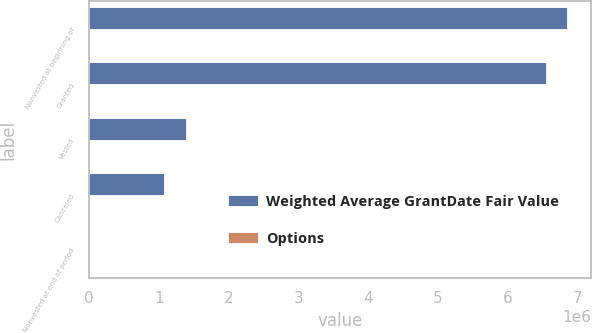<chart> <loc_0><loc_0><loc_500><loc_500><stacked_bar_chart><ecel><fcel>Nonvested at beginning of<fcel>Granted<fcel>Vested<fcel>Canceled<fcel>Nonvested at end of period<nl><fcel>Weighted Average GrantDate Fair Value<fcel>6.85085e+06<fcel>6.5475e+06<fcel>1.38312e+06<fcel>1.07888e+06<fcel>10.39<nl><fcel>Options<fcel>10.39<fcel>4.48<fcel>8.16<fcel>8.25<fcel>7.32<nl></chart> 